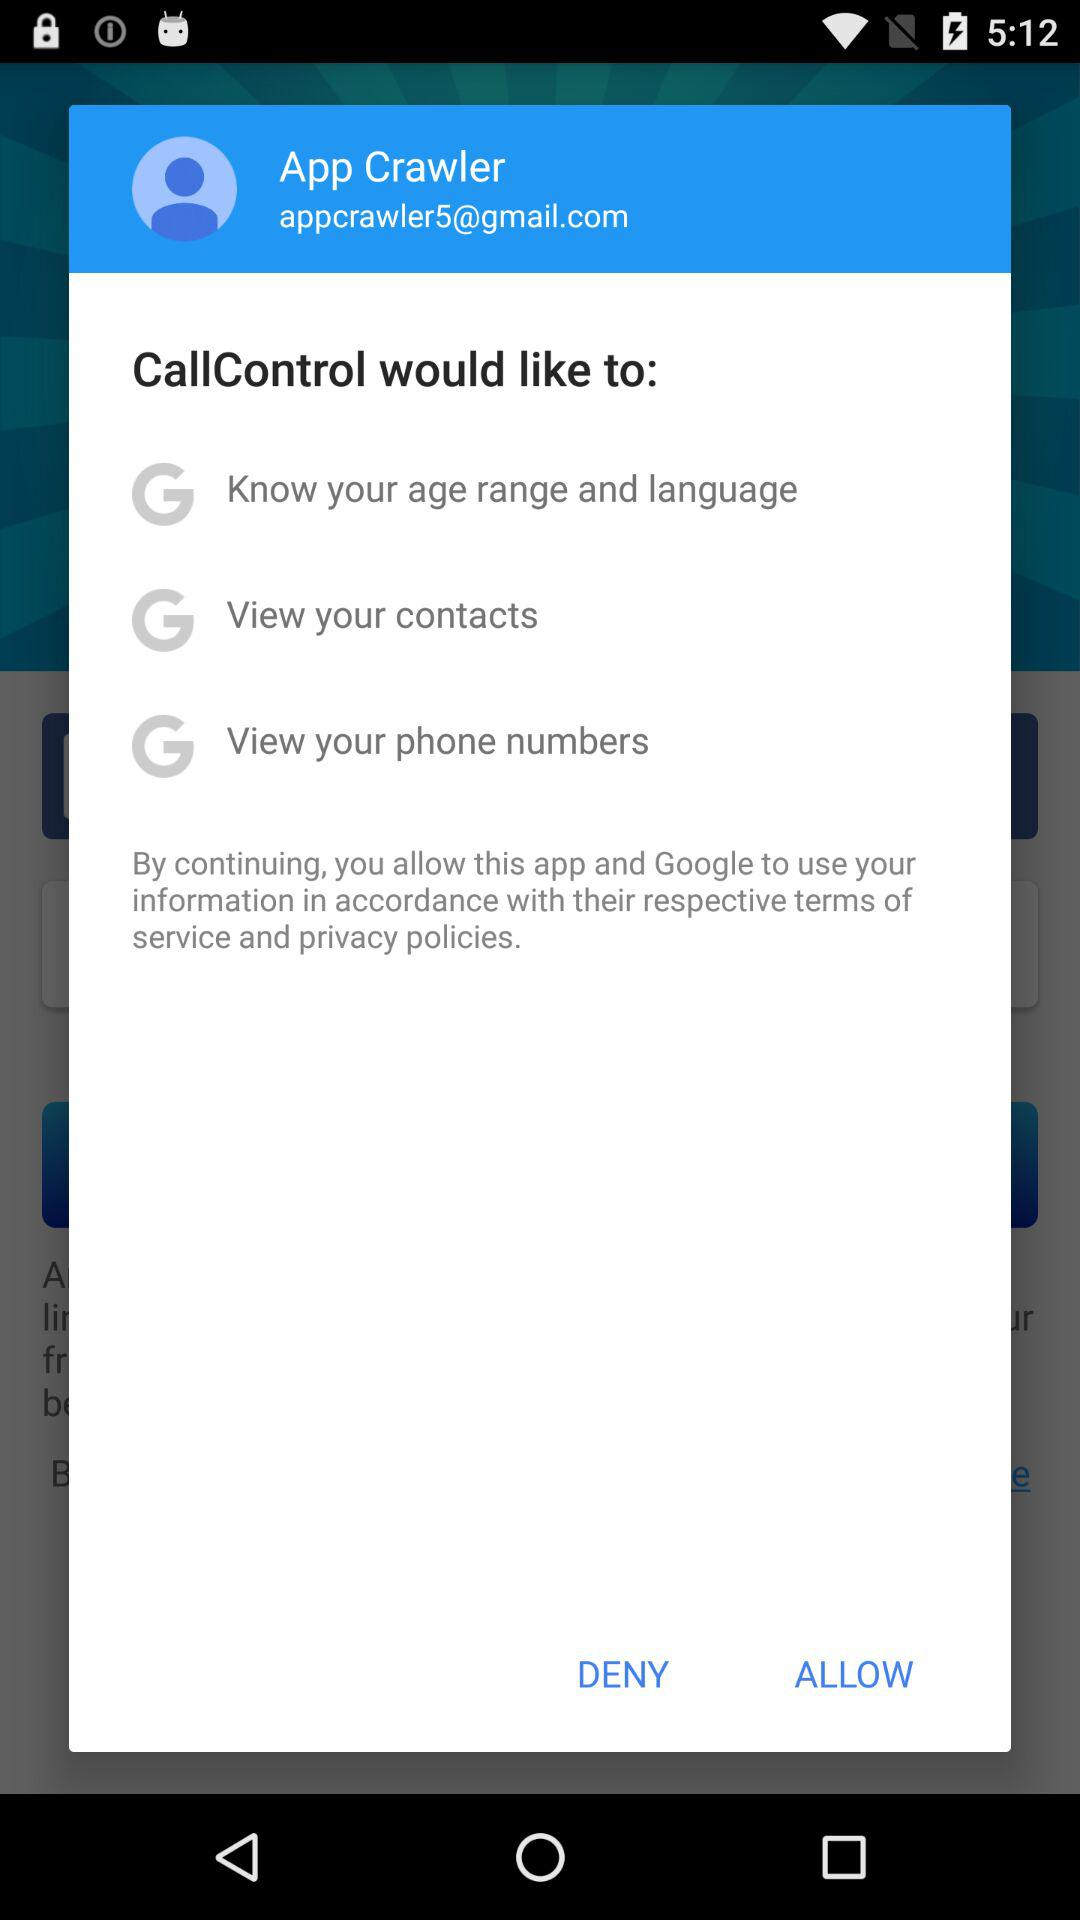What would "CallControl" like to do? "CallControl" would like to know your age range and language, view your contacts and view your phone numbers. 